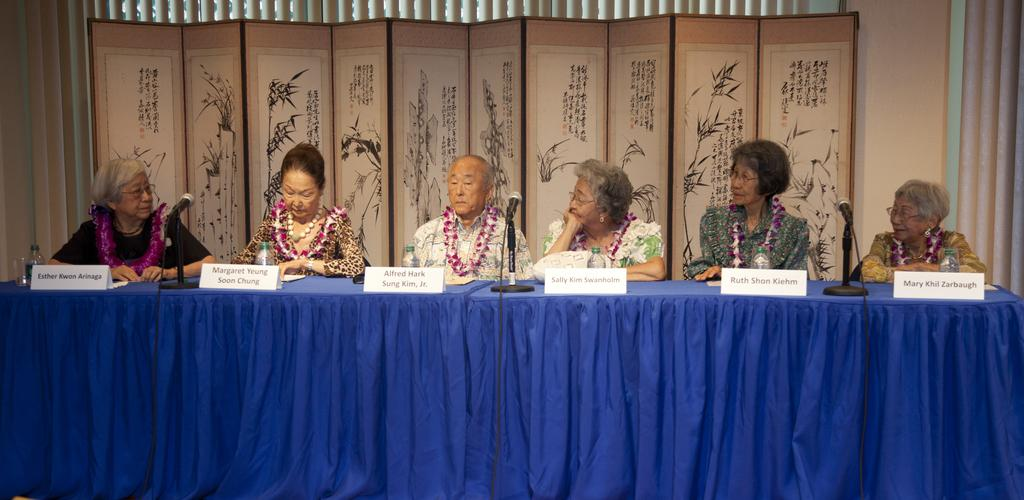How many people are sitting in the image? There are six persons sitting on chairs in the image. What objects are on the table in the image? There is a bottle and a microphone (mic) on the table in the image. What type of cracker is being traded between the persons in the image? There is no cracker present in the image, and no trading activity is depicted. 